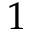<formula> <loc_0><loc_0><loc_500><loc_500>1</formula> 